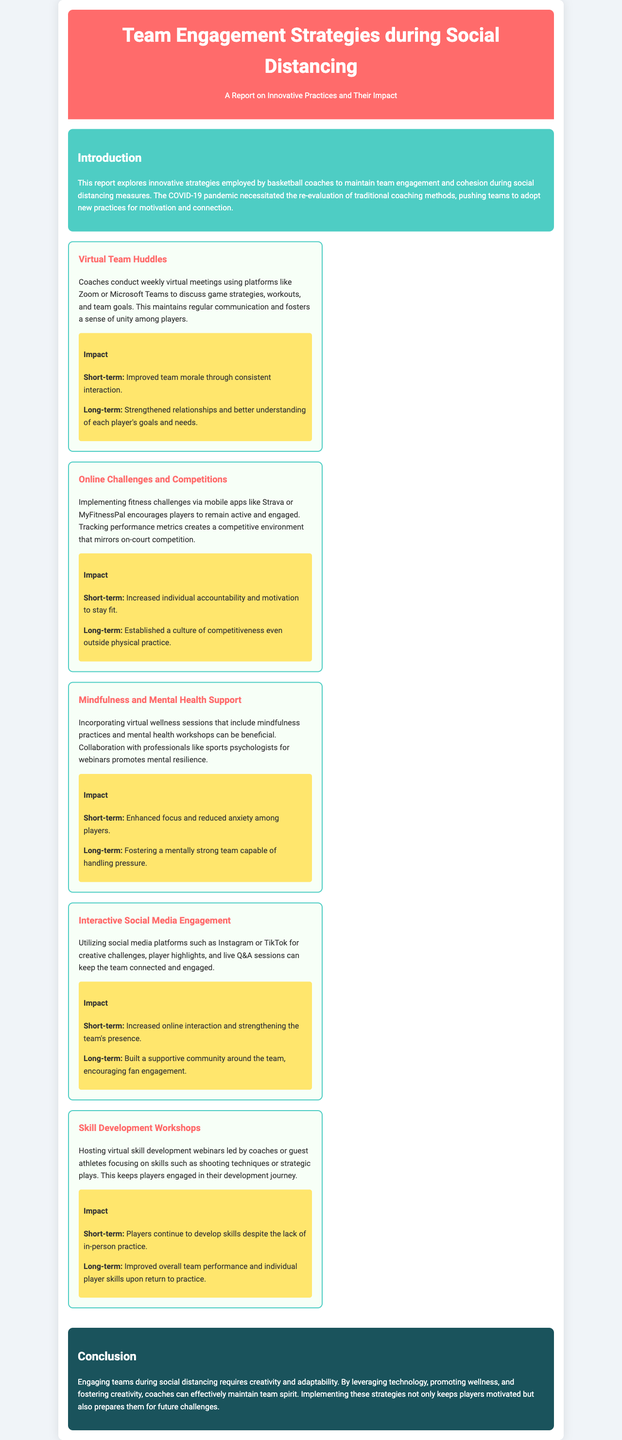what is the title of the report? The title can be found in the header section of the document.
Answer: Team Engagement Strategies during Social Distancing what online platform is mentioned for virtual meetings? The document specifies the platform used for virtual team huddles under the strategy section.
Answer: Zoom or Microsoft Teams what is a short-term impact of mindfulness support? The short-term impact is mentioned in the impact section of that strategy.
Answer: Enhanced focus how many strategies are listed in the report? The strategies are detailed in the strategies section, and the total count can be easily observed.
Answer: Five what type of challenges are implemented via mobile apps? Referring to the related strategy, the type of challenges can be found in that specific section.
Answer: Fitness challenges which color is used for the conclusion section? The background color of the conclusion is described in the document's styling.
Answer: Dark blue what is a long-term impact of online challenges? This impact can be found in the impact details for that specific strategy.
Answer: Established a culture of competitiveness what innovative practice involves skill development? The practice that focuses on skill development is described as a strategy in the report.
Answer: Skill Development Workshops 